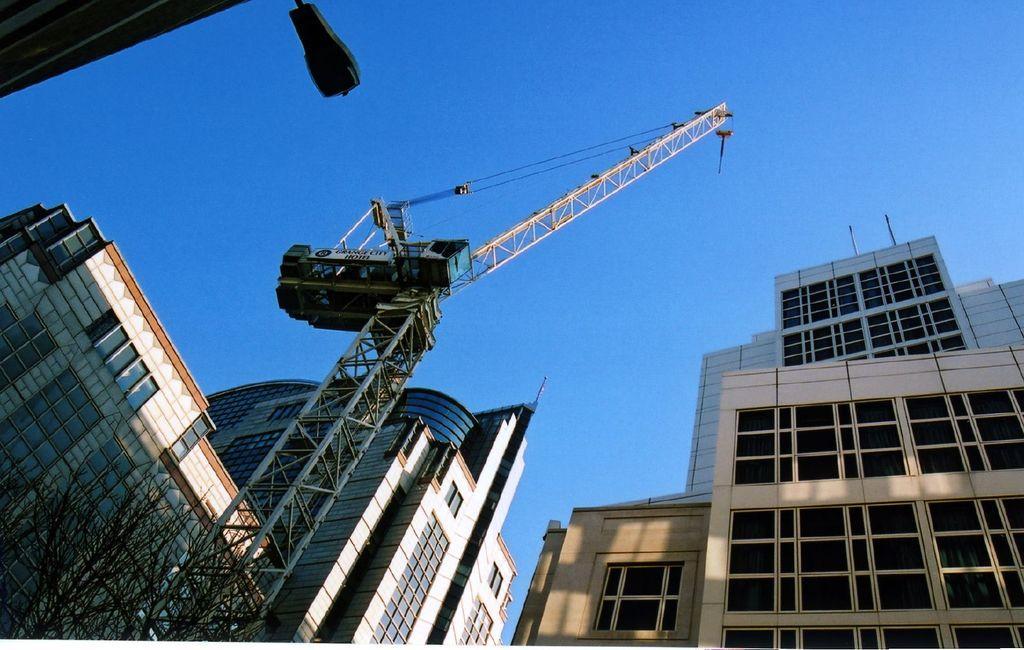How would you summarize this image in a sentence or two? In this image I can see a tree, a huge crane and few buildings. In the background I can see the sky. 